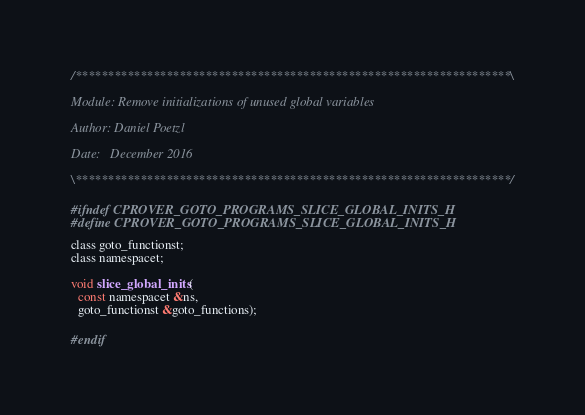<code> <loc_0><loc_0><loc_500><loc_500><_C_>/*******************************************************************\

Module: Remove initializations of unused global variables

Author: Daniel Poetzl

Date:   December 2016

\*******************************************************************/

#ifndef CPROVER_GOTO_PROGRAMS_SLICE_GLOBAL_INITS_H
#define CPROVER_GOTO_PROGRAMS_SLICE_GLOBAL_INITS_H

class goto_functionst;
class namespacet;

void slice_global_inits(
  const namespacet &ns,
  goto_functionst &goto_functions);

#endif
</code> 